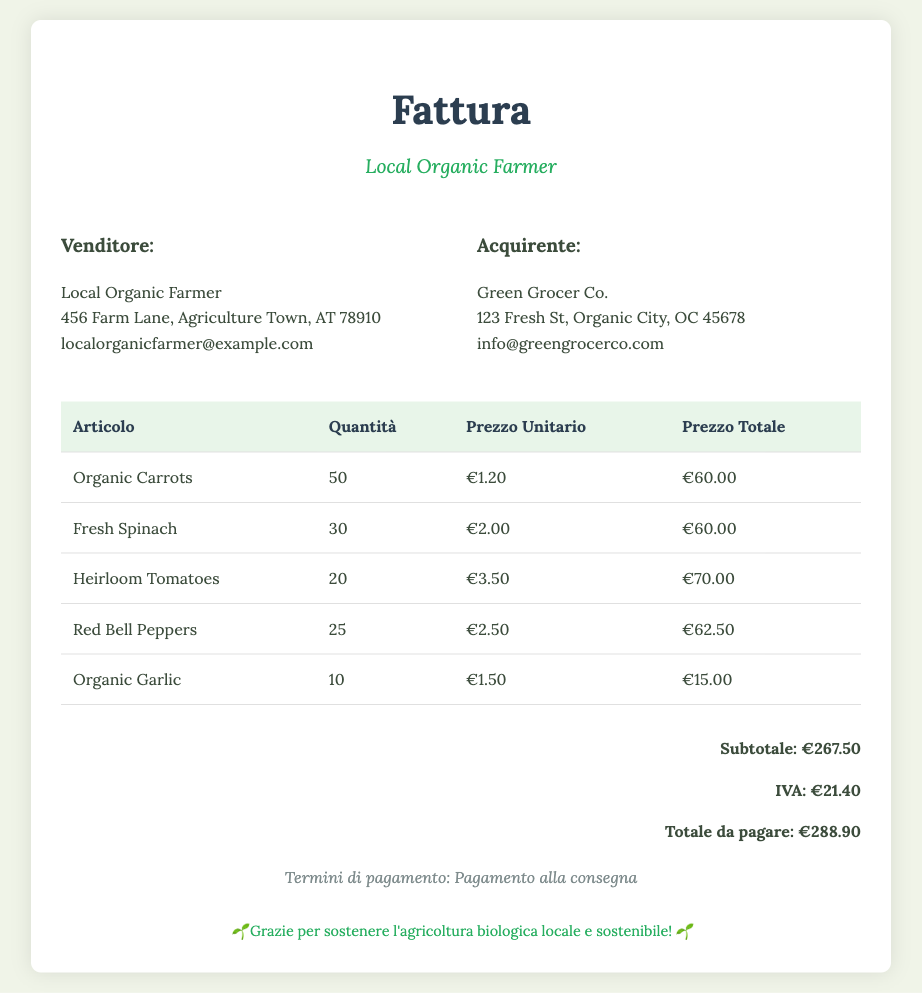what is the total amount due? The total amount due is clearly stated in the document as the final amount after subtotal and tax, which is €288.90.
Answer: €288.90 how many items of Organic Carrots were sold? The number of items sold for Organic Carrots is listed under the quantity column in the invoice. It states 50.
Answer: 50 what is the price per unit of Fresh Spinach? The price per unit of Fresh Spinach can be found in the respective row in the invoice, indicating €2.00.
Answer: €2.00 who is the buyer? The document lists Green Grocer Co. as the buyer, stated under the Acquirente section.
Answer: Green Grocer Co what is the subtotal amount before tax? The subtotal amount is calculated before adding the tax, which is shown as €267.50 in the total section.
Answer: €267.50 how much VAT is included? The VAT amount is specifically mentioned in the total section of the document as €21.40.
Answer: €21.40 how many Heirloom Tomatoes were purchased? The quantity of Heirloom Tomatoes purchased is documented in the table, which shows 20.
Answer: 20 what is the address of the seller? The seller’s address is provided in the invoice, which is 456 Farm Lane, Agriculture Town, AT 78910.
Answer: 456 Farm Lane, Agriculture Town, AT 78910 what are the payment terms? The payment terms are stated at the bottom of the document as "Pagamento alla consegna."
Answer: Pagamento alla consegna 